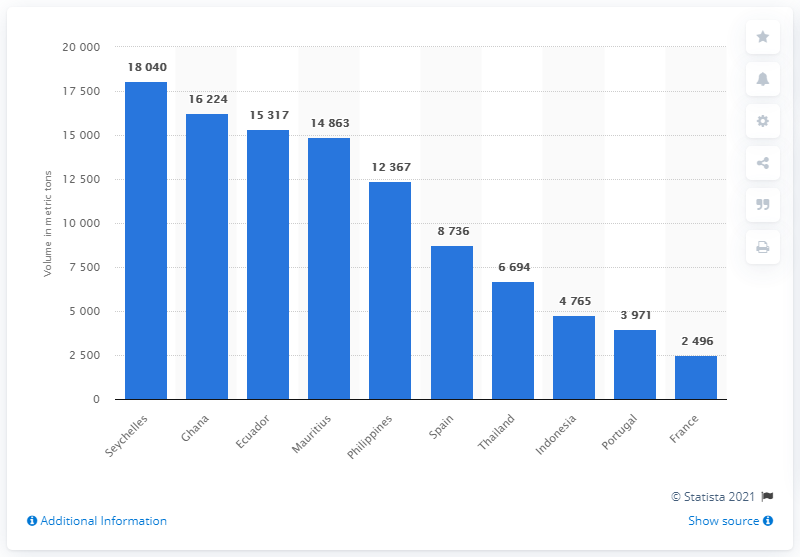Outline some significant characteristics in this image. In 2017, the Seychelles exported a total of 18,040 metric tons of tuna. 